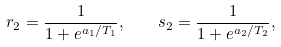Convert formula to latex. <formula><loc_0><loc_0><loc_500><loc_500>r _ { 2 } = \frac { 1 } { 1 + e ^ { a _ { 1 } / T _ { 1 } } } , \quad s _ { 2 } = \frac { 1 } { 1 + e ^ { a _ { 2 } / T _ { 2 } } } ,</formula> 